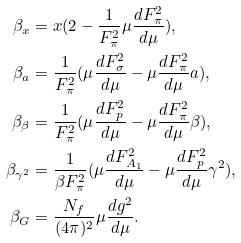<formula> <loc_0><loc_0><loc_500><loc_500>\beta _ { x } & = x ( 2 - \frac { 1 } { F _ { \pi } ^ { 2 } } \mu \frac { d F _ { \pi } ^ { 2 } } { d \mu } ) , \\ \beta _ { a } & = \frac { 1 } { F _ { \pi } ^ { 2 } } ( \mu \frac { d F _ { \sigma } ^ { 2 } } { d \mu } - \mu \frac { d F _ { \pi } ^ { 2 } } { d \mu } a ) , \\ \beta _ { \beta } & = \frac { 1 } { F _ { \pi } ^ { 2 } } ( \mu \frac { d F _ { p } ^ { 2 } } { d \mu } - \mu \frac { d F _ { \pi } ^ { 2 } } { d \mu } \beta ) , \\ \beta _ { \gamma ^ { 2 } } & = \frac { 1 } { \beta F _ { \pi } ^ { 2 } } ( \mu \frac { { d F _ { A _ { 1 } } ^ { 2 } } } { d \mu } - \mu \frac { d F _ { p } ^ { 2 } } { d \mu } \gamma ^ { 2 } ) , \\ \beta _ { G } & = \frac { N _ { f } } { ( 4 \pi ) ^ { 2 } } \mu \frac { d g ^ { 2 } } { d \mu } .</formula> 